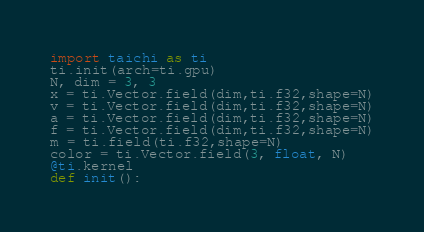Convert code to text. <code><loc_0><loc_0><loc_500><loc_500><_Python_>import taichi as ti
ti.init(arch=ti.gpu)
N, dim = 3, 3
x = ti.Vector.field(dim,ti.f32,shape=N)
v = ti.Vector.field(dim,ti.f32,shape=N)
a = ti.Vector.field(dim,ti.f32,shape=N)
f = ti.Vector.field(dim,ti.f32,shape=N)
m = ti.field(ti.f32,shape=N)
color = ti.Vector.field(3, float, N)
@ti.kernel 
def init():</code> 